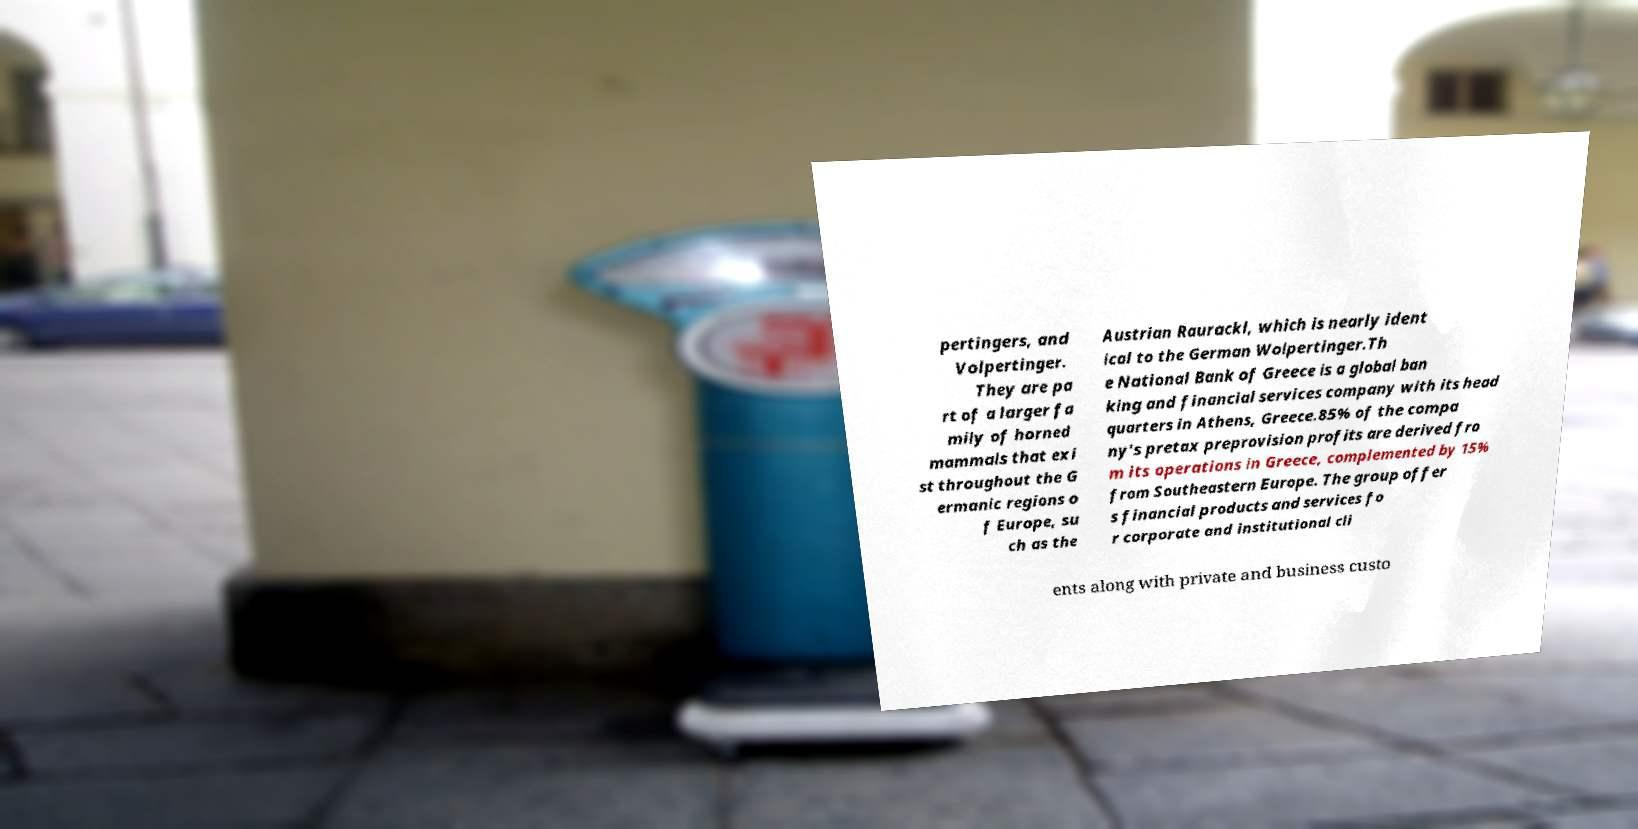Please identify and transcribe the text found in this image. pertingers, and Volpertinger. They are pa rt of a larger fa mily of horned mammals that exi st throughout the G ermanic regions o f Europe, su ch as the Austrian Raurackl, which is nearly ident ical to the German Wolpertinger.Th e National Bank of Greece is a global ban king and financial services company with its head quarters in Athens, Greece.85% of the compa ny's pretax preprovision profits are derived fro m its operations in Greece, complemented by 15% from Southeastern Europe. The group offer s financial products and services fo r corporate and institutional cli ents along with private and business custo 